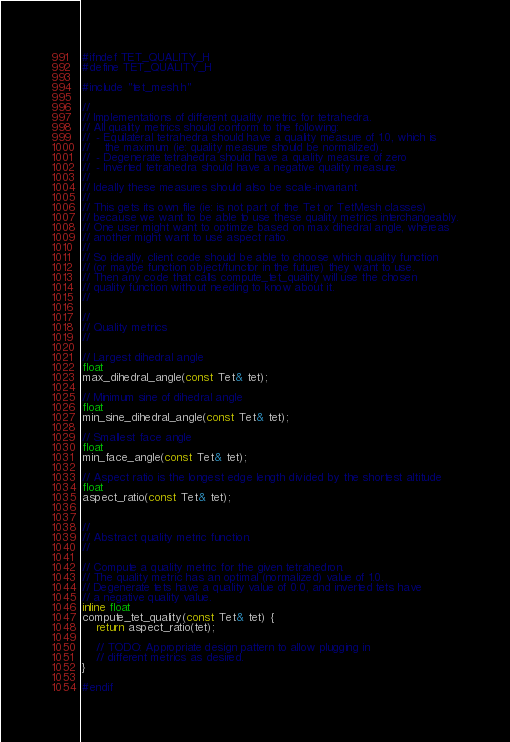<code> <loc_0><loc_0><loc_500><loc_500><_C_>#ifndef TET_QUALITY_H
#define TET_QUALITY_H

#include "tet_mesh.h"

//
// Implementations of different quality metric for tetrahedra.
// All quality metrics should conform to the following:
//  - Equilateral tetrahedra should have a quality measure of 1.0, which is 
//    the maximum (ie: quality measure should be normalized).
//  - Degenerate tetrahedra should have a quality measure of zero
//  - Inverted tetrahedra should have a negative quality measure.
//
// Ideally these measures should also be scale-invariant.
//
// This gets its own file (ie: is not part of the Tet or TetMesh classes)
// because we want to be able to use these quality metrics interchangeably.
// One user might want to optimize based on max dihedral angle, whereas
// another might want to use aspect ratio.
//
// So ideally, client code should be able to choose which quality function
// (or maybe function object/functor in the future) they want to use.
// Then any code that calls compute_tet_quality will use the chosen 
// quality function without needing to know about it.
//

//
// Quality metrics
//

// Largest dihedral angle
float
max_dihedral_angle(const Tet& tet);

// Minimum sine of dihedral angle
float
min_sine_dihedral_angle(const Tet& tet);

// Smallest face angle
float
min_face_angle(const Tet& tet);

// Aspect ratio is the longest edge length divided by the shortest altitude
float
aspect_ratio(const Tet& tet);


//
// Abstract quality metric function.
//

// Compute a quality metric for the given tetrahedron.
// The quality metric has an optimal (normalized) value of 1.0.
// Degenerate tets have a quality value of 0.0, and inverted tets have 
// a negative quality value.
inline float
compute_tet_quality(const Tet& tet) {
    return aspect_ratio(tet);

    // TODO: Appropriate design pattern to allow plugging in 
    // different metrics as desired.
}

#endif
</code> 